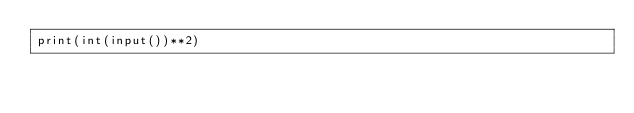<code> <loc_0><loc_0><loc_500><loc_500><_Python_>print(int(input())**2)</code> 